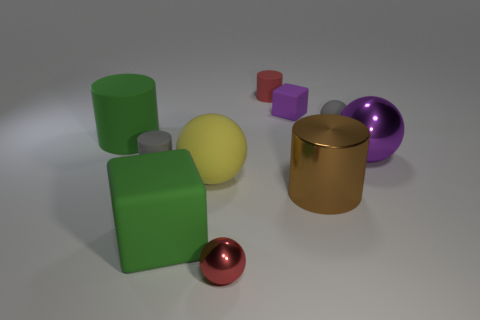There is a small ball in front of the gray matte cylinder; what material is it?
Keep it short and to the point. Metal. There is a big cylinder that is made of the same material as the small red sphere; what is its color?
Make the answer very short. Brown. What number of brown cylinders are the same size as the yellow rubber sphere?
Provide a succinct answer. 1. Is the size of the red matte object that is behind the green matte cylinder the same as the tiny purple thing?
Give a very brief answer. Yes. There is a large matte thing that is both in front of the green cylinder and left of the large matte sphere; what shape is it?
Offer a terse response. Cube. There is a big green rubber cylinder; are there any tiny metallic things on the left side of it?
Your response must be concise. No. Are there any other things that have the same shape as the red matte thing?
Ensure brevity in your answer.  Yes. Is the shape of the large yellow matte object the same as the small red rubber object?
Provide a short and direct response. No. Is the number of tiny red matte things that are on the left side of the small purple object the same as the number of green rubber objects behind the brown metallic cylinder?
Make the answer very short. Yes. What number of other things are the same material as the tiny red cylinder?
Offer a terse response. 6. 